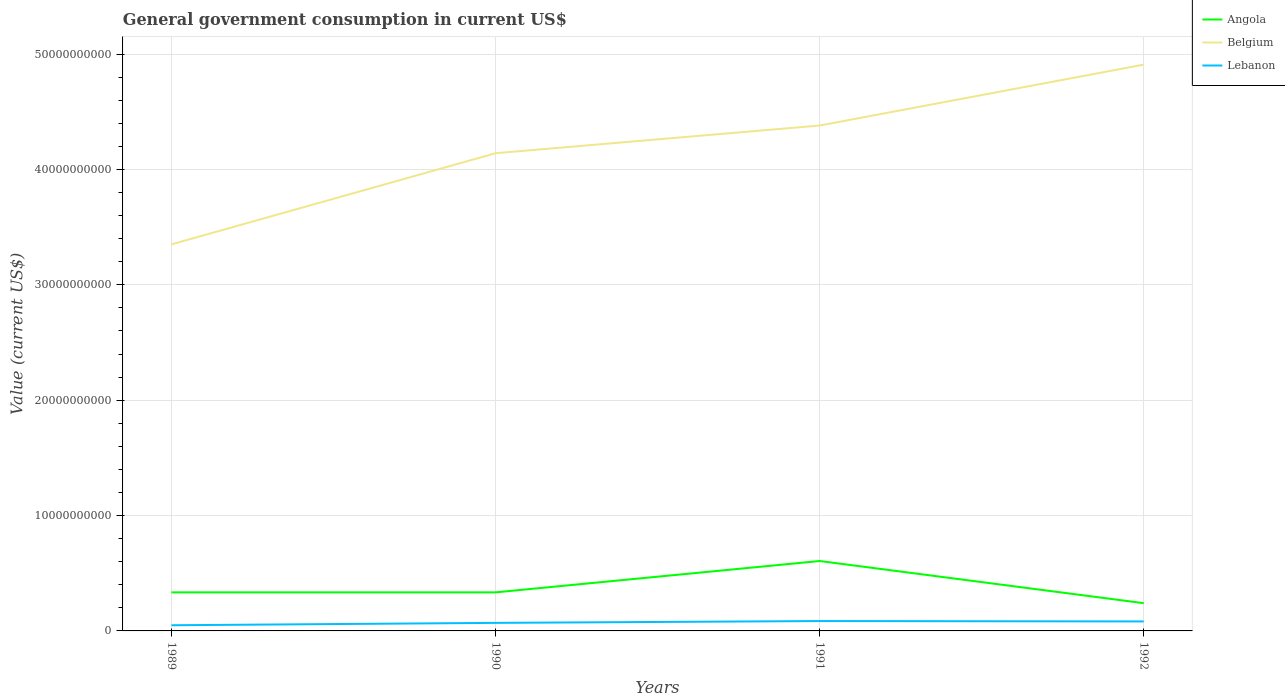How many different coloured lines are there?
Ensure brevity in your answer.  3. Is the number of lines equal to the number of legend labels?
Ensure brevity in your answer.  Yes. Across all years, what is the maximum government conusmption in Belgium?
Your response must be concise. 3.35e+1. What is the total government conusmption in Lebanon in the graph?
Your response must be concise. -1.25e+08. What is the difference between the highest and the second highest government conusmption in Angola?
Your answer should be compact. 3.65e+09. What is the difference between two consecutive major ticks on the Y-axis?
Provide a short and direct response. 1.00e+1. Does the graph contain grids?
Your answer should be compact. Yes. Where does the legend appear in the graph?
Keep it short and to the point. Top right. What is the title of the graph?
Your answer should be very brief. General government consumption in current US$. Does "Lesotho" appear as one of the legend labels in the graph?
Ensure brevity in your answer.  No. What is the label or title of the X-axis?
Keep it short and to the point. Years. What is the label or title of the Y-axis?
Provide a succinct answer. Value (current US$). What is the Value (current US$) in Angola in 1989?
Your response must be concise. 3.34e+09. What is the Value (current US$) in Belgium in 1989?
Your answer should be very brief. 3.35e+1. What is the Value (current US$) in Lebanon in 1989?
Ensure brevity in your answer.  4.91e+08. What is the Value (current US$) of Angola in 1990?
Make the answer very short. 3.34e+09. What is the Value (current US$) of Belgium in 1990?
Your response must be concise. 4.14e+1. What is the Value (current US$) in Lebanon in 1990?
Provide a succinct answer. 6.98e+08. What is the Value (current US$) of Angola in 1991?
Your response must be concise. 6.06e+09. What is the Value (current US$) in Belgium in 1991?
Your response must be concise. 4.38e+1. What is the Value (current US$) in Lebanon in 1991?
Keep it short and to the point. 8.55e+08. What is the Value (current US$) of Angola in 1992?
Make the answer very short. 2.40e+09. What is the Value (current US$) of Belgium in 1992?
Your answer should be very brief. 4.91e+1. What is the Value (current US$) in Lebanon in 1992?
Provide a succinct answer. 8.23e+08. Across all years, what is the maximum Value (current US$) of Angola?
Make the answer very short. 6.06e+09. Across all years, what is the maximum Value (current US$) in Belgium?
Provide a short and direct response. 4.91e+1. Across all years, what is the maximum Value (current US$) of Lebanon?
Offer a terse response. 8.55e+08. Across all years, what is the minimum Value (current US$) in Angola?
Provide a succinct answer. 2.40e+09. Across all years, what is the minimum Value (current US$) in Belgium?
Keep it short and to the point. 3.35e+1. Across all years, what is the minimum Value (current US$) in Lebanon?
Give a very brief answer. 4.91e+08. What is the total Value (current US$) of Angola in the graph?
Ensure brevity in your answer.  1.51e+1. What is the total Value (current US$) of Belgium in the graph?
Your answer should be compact. 1.68e+11. What is the total Value (current US$) of Lebanon in the graph?
Offer a very short reply. 2.87e+09. What is the difference between the Value (current US$) of Angola in 1989 and that in 1990?
Ensure brevity in your answer.  0. What is the difference between the Value (current US$) in Belgium in 1989 and that in 1990?
Ensure brevity in your answer.  -7.90e+09. What is the difference between the Value (current US$) in Lebanon in 1989 and that in 1990?
Your response must be concise. -2.06e+08. What is the difference between the Value (current US$) of Angola in 1989 and that in 1991?
Provide a short and direct response. -2.72e+09. What is the difference between the Value (current US$) of Belgium in 1989 and that in 1991?
Offer a terse response. -1.03e+1. What is the difference between the Value (current US$) in Lebanon in 1989 and that in 1991?
Provide a short and direct response. -3.64e+08. What is the difference between the Value (current US$) of Angola in 1989 and that in 1992?
Give a very brief answer. 9.37e+08. What is the difference between the Value (current US$) in Belgium in 1989 and that in 1992?
Provide a succinct answer. -1.56e+1. What is the difference between the Value (current US$) in Lebanon in 1989 and that in 1992?
Provide a succinct answer. -3.31e+08. What is the difference between the Value (current US$) of Angola in 1990 and that in 1991?
Provide a succinct answer. -2.72e+09. What is the difference between the Value (current US$) of Belgium in 1990 and that in 1991?
Provide a short and direct response. -2.40e+09. What is the difference between the Value (current US$) in Lebanon in 1990 and that in 1991?
Make the answer very short. -1.58e+08. What is the difference between the Value (current US$) in Angola in 1990 and that in 1992?
Give a very brief answer. 9.37e+08. What is the difference between the Value (current US$) of Belgium in 1990 and that in 1992?
Provide a succinct answer. -7.68e+09. What is the difference between the Value (current US$) in Lebanon in 1990 and that in 1992?
Give a very brief answer. -1.25e+08. What is the difference between the Value (current US$) of Angola in 1991 and that in 1992?
Your answer should be compact. 3.65e+09. What is the difference between the Value (current US$) of Belgium in 1991 and that in 1992?
Your answer should be compact. -5.28e+09. What is the difference between the Value (current US$) of Lebanon in 1991 and that in 1992?
Give a very brief answer. 3.28e+07. What is the difference between the Value (current US$) in Angola in 1989 and the Value (current US$) in Belgium in 1990?
Give a very brief answer. -3.81e+1. What is the difference between the Value (current US$) in Angola in 1989 and the Value (current US$) in Lebanon in 1990?
Ensure brevity in your answer.  2.64e+09. What is the difference between the Value (current US$) in Belgium in 1989 and the Value (current US$) in Lebanon in 1990?
Keep it short and to the point. 3.28e+1. What is the difference between the Value (current US$) of Angola in 1989 and the Value (current US$) of Belgium in 1991?
Offer a terse response. -4.05e+1. What is the difference between the Value (current US$) of Angola in 1989 and the Value (current US$) of Lebanon in 1991?
Keep it short and to the point. 2.49e+09. What is the difference between the Value (current US$) of Belgium in 1989 and the Value (current US$) of Lebanon in 1991?
Offer a very short reply. 3.27e+1. What is the difference between the Value (current US$) of Angola in 1989 and the Value (current US$) of Belgium in 1992?
Give a very brief answer. -4.57e+1. What is the difference between the Value (current US$) in Angola in 1989 and the Value (current US$) in Lebanon in 1992?
Your answer should be very brief. 2.52e+09. What is the difference between the Value (current US$) of Belgium in 1989 and the Value (current US$) of Lebanon in 1992?
Make the answer very short. 3.27e+1. What is the difference between the Value (current US$) of Angola in 1990 and the Value (current US$) of Belgium in 1991?
Your answer should be very brief. -4.05e+1. What is the difference between the Value (current US$) of Angola in 1990 and the Value (current US$) of Lebanon in 1991?
Make the answer very short. 2.49e+09. What is the difference between the Value (current US$) in Belgium in 1990 and the Value (current US$) in Lebanon in 1991?
Your answer should be compact. 4.06e+1. What is the difference between the Value (current US$) of Angola in 1990 and the Value (current US$) of Belgium in 1992?
Make the answer very short. -4.57e+1. What is the difference between the Value (current US$) in Angola in 1990 and the Value (current US$) in Lebanon in 1992?
Your response must be concise. 2.52e+09. What is the difference between the Value (current US$) in Belgium in 1990 and the Value (current US$) in Lebanon in 1992?
Offer a terse response. 4.06e+1. What is the difference between the Value (current US$) of Angola in 1991 and the Value (current US$) of Belgium in 1992?
Provide a short and direct response. -4.30e+1. What is the difference between the Value (current US$) of Angola in 1991 and the Value (current US$) of Lebanon in 1992?
Provide a succinct answer. 5.24e+09. What is the difference between the Value (current US$) in Belgium in 1991 and the Value (current US$) in Lebanon in 1992?
Make the answer very short. 4.30e+1. What is the average Value (current US$) in Angola per year?
Keep it short and to the point. 3.79e+09. What is the average Value (current US$) in Belgium per year?
Keep it short and to the point. 4.20e+1. What is the average Value (current US$) in Lebanon per year?
Provide a short and direct response. 7.17e+08. In the year 1989, what is the difference between the Value (current US$) in Angola and Value (current US$) in Belgium?
Your response must be concise. -3.02e+1. In the year 1989, what is the difference between the Value (current US$) of Angola and Value (current US$) of Lebanon?
Give a very brief answer. 2.85e+09. In the year 1989, what is the difference between the Value (current US$) in Belgium and Value (current US$) in Lebanon?
Make the answer very short. 3.30e+1. In the year 1990, what is the difference between the Value (current US$) of Angola and Value (current US$) of Belgium?
Your answer should be compact. -3.81e+1. In the year 1990, what is the difference between the Value (current US$) of Angola and Value (current US$) of Lebanon?
Ensure brevity in your answer.  2.64e+09. In the year 1990, what is the difference between the Value (current US$) in Belgium and Value (current US$) in Lebanon?
Provide a succinct answer. 4.07e+1. In the year 1991, what is the difference between the Value (current US$) in Angola and Value (current US$) in Belgium?
Ensure brevity in your answer.  -3.77e+1. In the year 1991, what is the difference between the Value (current US$) in Angola and Value (current US$) in Lebanon?
Provide a short and direct response. 5.20e+09. In the year 1991, what is the difference between the Value (current US$) in Belgium and Value (current US$) in Lebanon?
Provide a short and direct response. 4.30e+1. In the year 1992, what is the difference between the Value (current US$) of Angola and Value (current US$) of Belgium?
Keep it short and to the point. -4.67e+1. In the year 1992, what is the difference between the Value (current US$) in Angola and Value (current US$) in Lebanon?
Offer a very short reply. 1.58e+09. In the year 1992, what is the difference between the Value (current US$) of Belgium and Value (current US$) of Lebanon?
Your answer should be very brief. 4.83e+1. What is the ratio of the Value (current US$) of Angola in 1989 to that in 1990?
Provide a succinct answer. 1. What is the ratio of the Value (current US$) in Belgium in 1989 to that in 1990?
Give a very brief answer. 0.81. What is the ratio of the Value (current US$) in Lebanon in 1989 to that in 1990?
Your answer should be compact. 0.7. What is the ratio of the Value (current US$) in Angola in 1989 to that in 1991?
Your answer should be compact. 0.55. What is the ratio of the Value (current US$) in Belgium in 1989 to that in 1991?
Offer a terse response. 0.76. What is the ratio of the Value (current US$) of Lebanon in 1989 to that in 1991?
Your answer should be very brief. 0.57. What is the ratio of the Value (current US$) in Angola in 1989 to that in 1992?
Offer a terse response. 1.39. What is the ratio of the Value (current US$) in Belgium in 1989 to that in 1992?
Make the answer very short. 0.68. What is the ratio of the Value (current US$) in Lebanon in 1989 to that in 1992?
Make the answer very short. 0.6. What is the ratio of the Value (current US$) of Angola in 1990 to that in 1991?
Your answer should be very brief. 0.55. What is the ratio of the Value (current US$) of Belgium in 1990 to that in 1991?
Make the answer very short. 0.95. What is the ratio of the Value (current US$) of Lebanon in 1990 to that in 1991?
Make the answer very short. 0.82. What is the ratio of the Value (current US$) of Angola in 1990 to that in 1992?
Your answer should be compact. 1.39. What is the ratio of the Value (current US$) of Belgium in 1990 to that in 1992?
Make the answer very short. 0.84. What is the ratio of the Value (current US$) in Lebanon in 1990 to that in 1992?
Make the answer very short. 0.85. What is the ratio of the Value (current US$) in Angola in 1991 to that in 1992?
Your answer should be compact. 2.52. What is the ratio of the Value (current US$) of Belgium in 1991 to that in 1992?
Make the answer very short. 0.89. What is the ratio of the Value (current US$) in Lebanon in 1991 to that in 1992?
Your answer should be very brief. 1.04. What is the difference between the highest and the second highest Value (current US$) of Angola?
Keep it short and to the point. 2.72e+09. What is the difference between the highest and the second highest Value (current US$) in Belgium?
Offer a terse response. 5.28e+09. What is the difference between the highest and the second highest Value (current US$) of Lebanon?
Your answer should be compact. 3.28e+07. What is the difference between the highest and the lowest Value (current US$) of Angola?
Make the answer very short. 3.65e+09. What is the difference between the highest and the lowest Value (current US$) of Belgium?
Ensure brevity in your answer.  1.56e+1. What is the difference between the highest and the lowest Value (current US$) of Lebanon?
Your answer should be compact. 3.64e+08. 